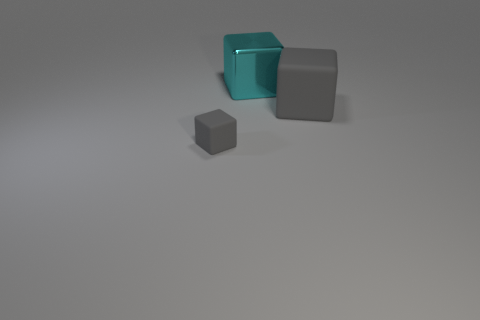Are there any large gray objects on the right side of the rubber object that is in front of the big gray object?
Provide a succinct answer. Yes. There is a gray cube that is to the right of the thing in front of the large rubber thing; how many big cyan cubes are to the left of it?
Provide a short and direct response. 1. What is the color of the thing that is both in front of the cyan block and on the left side of the big gray rubber thing?
Give a very brief answer. Gray. How many metallic objects are the same color as the big matte block?
Offer a very short reply. 0. How many cubes are either large red rubber things or cyan things?
Give a very brief answer. 1. There is a object that is the same size as the shiny block; what color is it?
Provide a succinct answer. Gray. Are there any big objects right of the thing that is behind the rubber object right of the small rubber thing?
Ensure brevity in your answer.  Yes. What size is the cyan block?
Your answer should be very brief. Large. How many objects are large purple cubes or small gray cubes?
Provide a succinct answer. 1. What is the color of the large block that is made of the same material as the tiny gray object?
Your answer should be compact. Gray. 